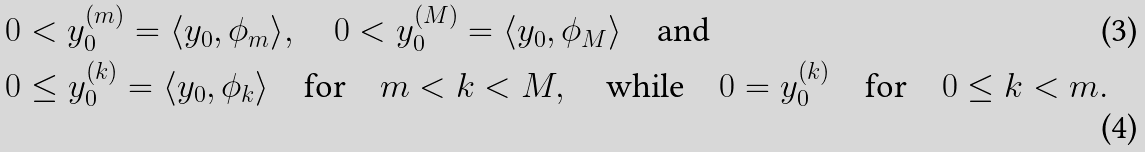Convert formula to latex. <formula><loc_0><loc_0><loc_500><loc_500>& 0 < y _ { 0 } ^ { ( m ) } = \langle y _ { 0 } , \phi _ { m } \rangle , \quad 0 < y _ { 0 } ^ { ( M ) } = \langle y _ { 0 } , \phi _ { M } \rangle \quad \text {and} \\ & 0 \leq y _ { 0 } ^ { ( k ) } = \langle y _ { 0 } , \phi _ { k } \rangle \quad \text {for} \quad m < k < M , \quad \text {while} \quad 0 = y _ { 0 } ^ { ( k ) } \quad \text {for} \quad 0 \leq k < m .</formula> 